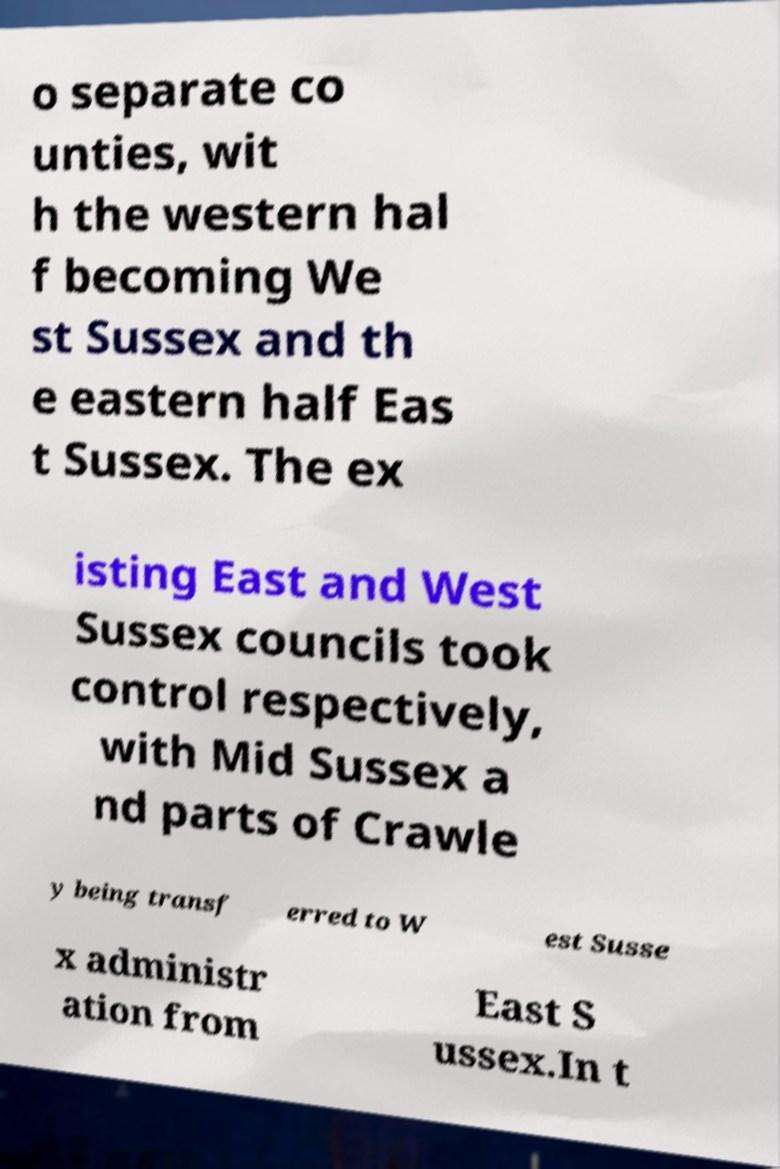Could you assist in decoding the text presented in this image and type it out clearly? o separate co unties, wit h the western hal f becoming We st Sussex and th e eastern half Eas t Sussex. The ex isting East and West Sussex councils took control respectively, with Mid Sussex a nd parts of Crawle y being transf erred to W est Susse x administr ation from East S ussex.In t 